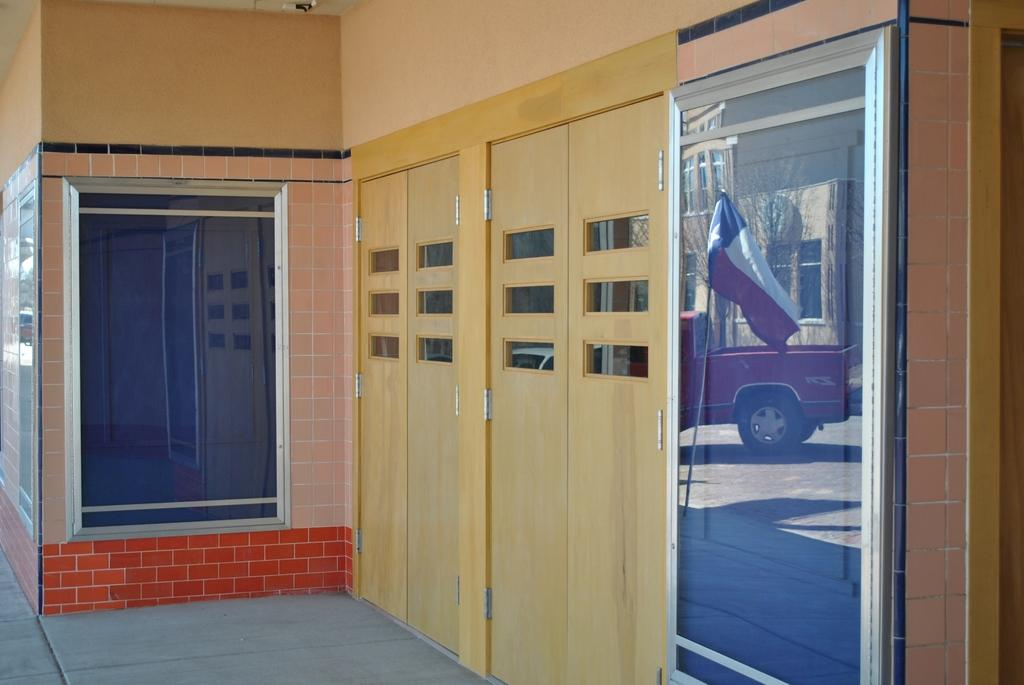What type of surface is visible in the image? There is a glass surface in the image. What can be seen reflected on the glass surface? The reflection of a car is visible on the glass surface. What color are the doors in the image? There are cream-colored doors in the image. What is the color of the wall in the image? There is an orange-colored wall in the image. What other object is present in the image? There is a flag in the image. How many mice are hiding behind the orange-colored wall in the image? There are no mice present in the image; it only features a glass surface, cream-colored doors, a flag, and an orange-colored wall. What type of jam is being served on the glass surface in the image? There is no jam present in the image; it only features a glass surface with a car's reflection and cream-colored doors. 